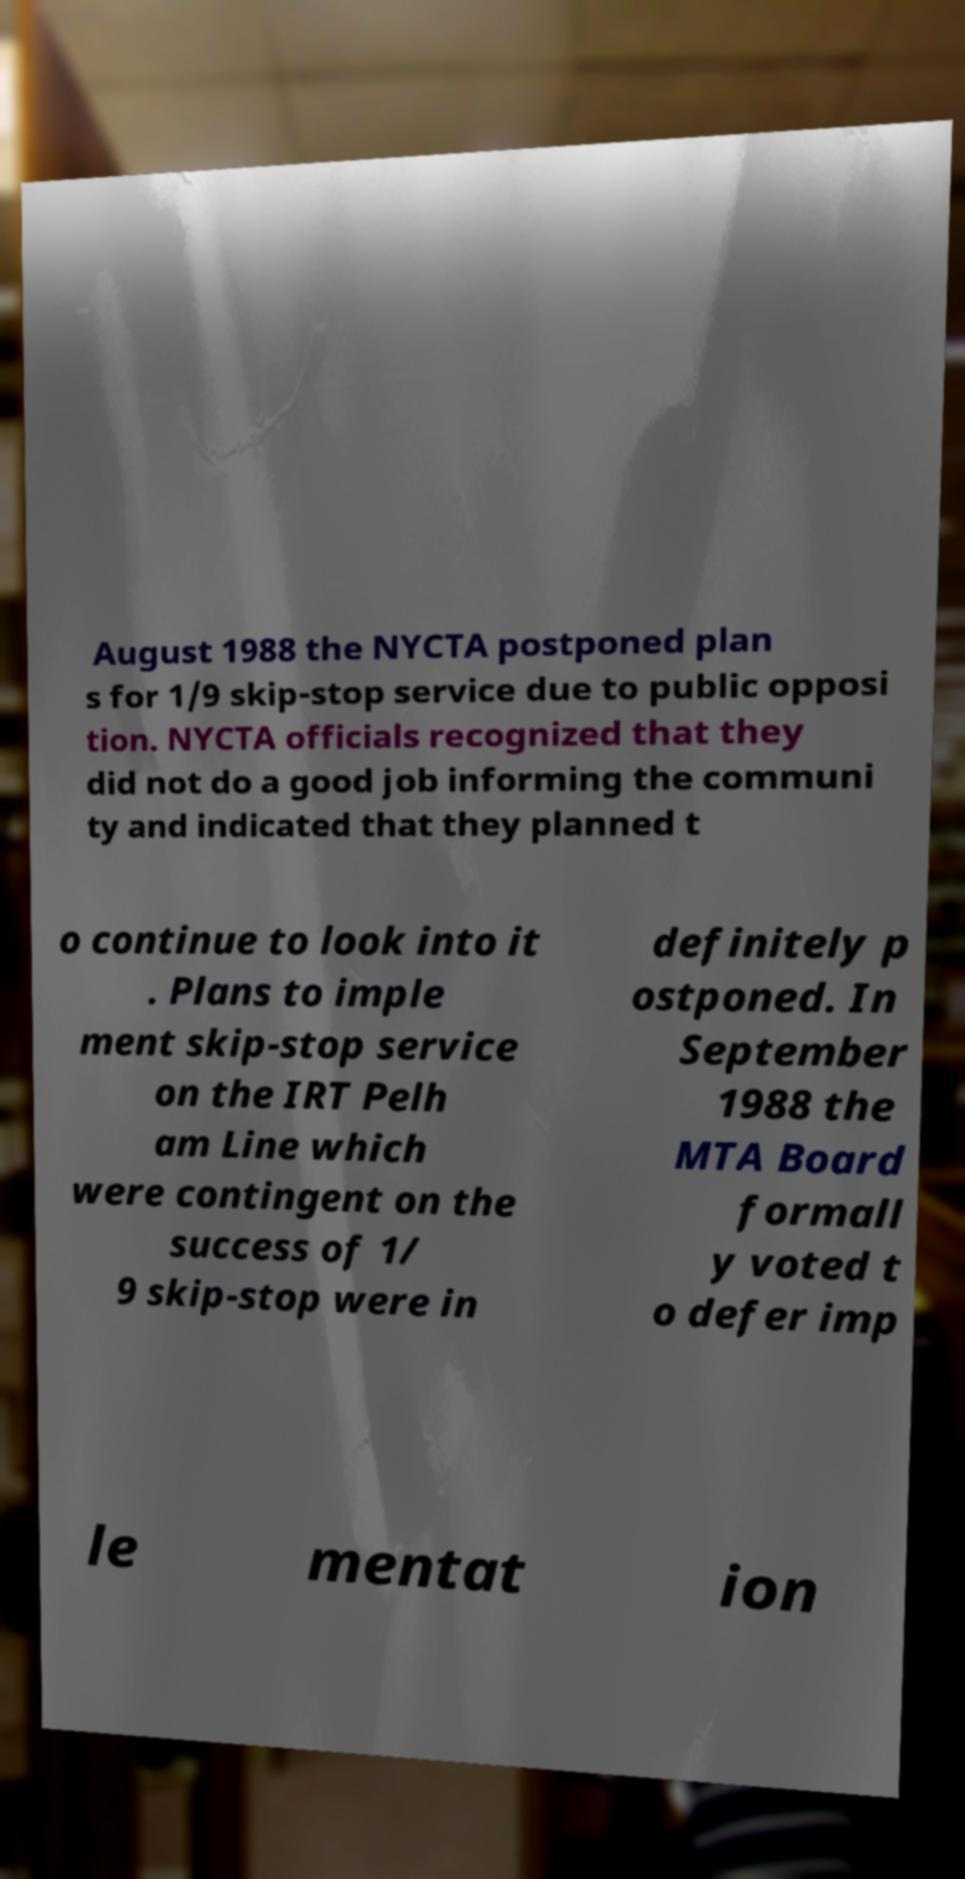I need the written content from this picture converted into text. Can you do that? August 1988 the NYCTA postponed plan s for 1/9 skip-stop service due to public opposi tion. NYCTA officials recognized that they did not do a good job informing the communi ty and indicated that they planned t o continue to look into it . Plans to imple ment skip-stop service on the IRT Pelh am Line which were contingent on the success of 1/ 9 skip-stop were in definitely p ostponed. In September 1988 the MTA Board formall y voted t o defer imp le mentat ion 